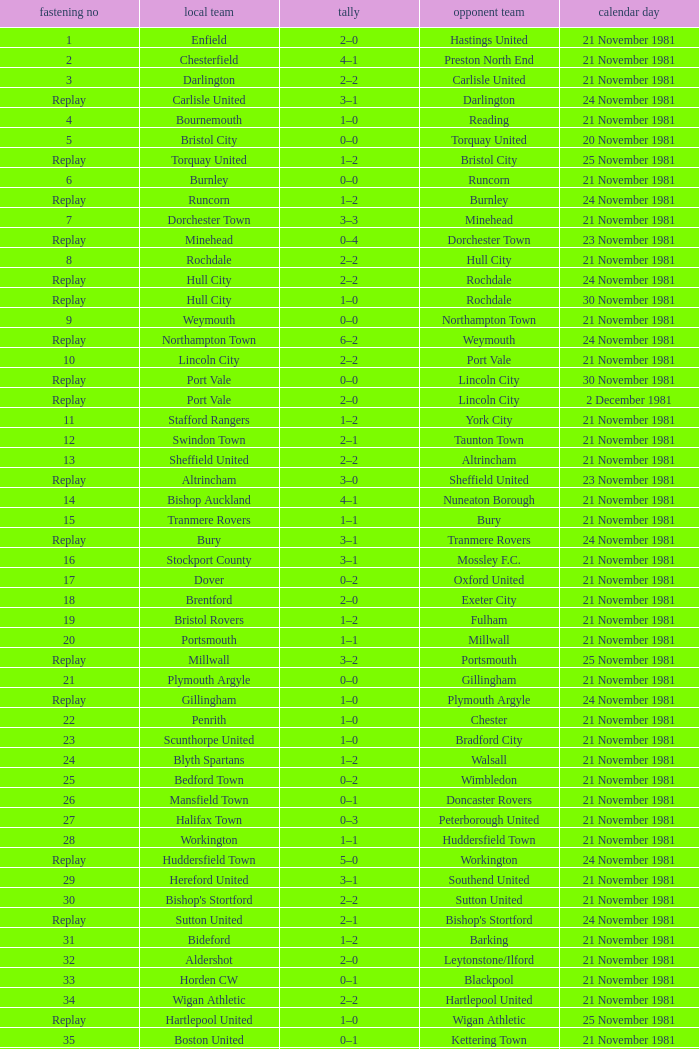Minehead has what tie number? Replay. Give me the full table as a dictionary. {'header': ['fastening no', 'local team', 'tally', 'opponent team', 'calendar day'], 'rows': [['1', 'Enfield', '2–0', 'Hastings United', '21 November 1981'], ['2', 'Chesterfield', '4–1', 'Preston North End', '21 November 1981'], ['3', 'Darlington', '2–2', 'Carlisle United', '21 November 1981'], ['Replay', 'Carlisle United', '3–1', 'Darlington', '24 November 1981'], ['4', 'Bournemouth', '1–0', 'Reading', '21 November 1981'], ['5', 'Bristol City', '0–0', 'Torquay United', '20 November 1981'], ['Replay', 'Torquay United', '1–2', 'Bristol City', '25 November 1981'], ['6', 'Burnley', '0–0', 'Runcorn', '21 November 1981'], ['Replay', 'Runcorn', '1–2', 'Burnley', '24 November 1981'], ['7', 'Dorchester Town', '3–3', 'Minehead', '21 November 1981'], ['Replay', 'Minehead', '0–4', 'Dorchester Town', '23 November 1981'], ['8', 'Rochdale', '2–2', 'Hull City', '21 November 1981'], ['Replay', 'Hull City', '2–2', 'Rochdale', '24 November 1981'], ['Replay', 'Hull City', '1–0', 'Rochdale', '30 November 1981'], ['9', 'Weymouth', '0–0', 'Northampton Town', '21 November 1981'], ['Replay', 'Northampton Town', '6–2', 'Weymouth', '24 November 1981'], ['10', 'Lincoln City', '2–2', 'Port Vale', '21 November 1981'], ['Replay', 'Port Vale', '0–0', 'Lincoln City', '30 November 1981'], ['Replay', 'Port Vale', '2–0', 'Lincoln City', '2 December 1981'], ['11', 'Stafford Rangers', '1–2', 'York City', '21 November 1981'], ['12', 'Swindon Town', '2–1', 'Taunton Town', '21 November 1981'], ['13', 'Sheffield United', '2–2', 'Altrincham', '21 November 1981'], ['Replay', 'Altrincham', '3–0', 'Sheffield United', '23 November 1981'], ['14', 'Bishop Auckland', '4–1', 'Nuneaton Borough', '21 November 1981'], ['15', 'Tranmere Rovers', '1–1', 'Bury', '21 November 1981'], ['Replay', 'Bury', '3–1', 'Tranmere Rovers', '24 November 1981'], ['16', 'Stockport County', '3–1', 'Mossley F.C.', '21 November 1981'], ['17', 'Dover', '0–2', 'Oxford United', '21 November 1981'], ['18', 'Brentford', '2–0', 'Exeter City', '21 November 1981'], ['19', 'Bristol Rovers', '1–2', 'Fulham', '21 November 1981'], ['20', 'Portsmouth', '1–1', 'Millwall', '21 November 1981'], ['Replay', 'Millwall', '3–2', 'Portsmouth', '25 November 1981'], ['21', 'Plymouth Argyle', '0–0', 'Gillingham', '21 November 1981'], ['Replay', 'Gillingham', '1–0', 'Plymouth Argyle', '24 November 1981'], ['22', 'Penrith', '1–0', 'Chester', '21 November 1981'], ['23', 'Scunthorpe United', '1–0', 'Bradford City', '21 November 1981'], ['24', 'Blyth Spartans', '1–2', 'Walsall', '21 November 1981'], ['25', 'Bedford Town', '0–2', 'Wimbledon', '21 November 1981'], ['26', 'Mansfield Town', '0–1', 'Doncaster Rovers', '21 November 1981'], ['27', 'Halifax Town', '0–3', 'Peterborough United', '21 November 1981'], ['28', 'Workington', '1–1', 'Huddersfield Town', '21 November 1981'], ['Replay', 'Huddersfield Town', '5–0', 'Workington', '24 November 1981'], ['29', 'Hereford United', '3–1', 'Southend United', '21 November 1981'], ['30', "Bishop's Stortford", '2–2', 'Sutton United', '21 November 1981'], ['Replay', 'Sutton United', '2–1', "Bishop's Stortford", '24 November 1981'], ['31', 'Bideford', '1–2', 'Barking', '21 November 1981'], ['32', 'Aldershot', '2–0', 'Leytonstone/Ilford', '21 November 1981'], ['33', 'Horden CW', '0–1', 'Blackpool', '21 November 1981'], ['34', 'Wigan Athletic', '2–2', 'Hartlepool United', '21 November 1981'], ['Replay', 'Hartlepool United', '1–0', 'Wigan Athletic', '25 November 1981'], ['35', 'Boston United', '0–1', 'Kettering Town', '21 November 1981'], ['36', 'Harlow Town', '0–0', 'Barnet', '21 November 1981'], ['Replay', 'Barnet', '1–0', 'Harlow Town', '24 November 1981'], ['37', 'Colchester United', '2–0', 'Newport County', '21 November 1981'], ['38', 'Hendon', '1–1', 'Wycombe Wanderers', '21 November 1981'], ['Replay', 'Wycombe Wanderers', '2–0', 'Hendon', '24 November 1981'], ['39', 'Dagenham', '2–2', 'Yeovil Town', '21 November 1981'], ['Replay', 'Yeovil Town', '0–1', 'Dagenham', '25 November 1981'], ['40', 'Willenhall Town', '0–1', 'Crewe Alexandra', '21 November 1981']]} 